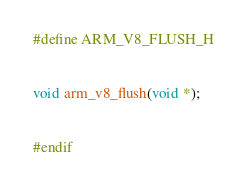Convert code to text. <code><loc_0><loc_0><loc_500><loc_500><_C_>#define ARM_V8_FLUSH_H


void arm_v8_flush(void *);


#endif
</code> 